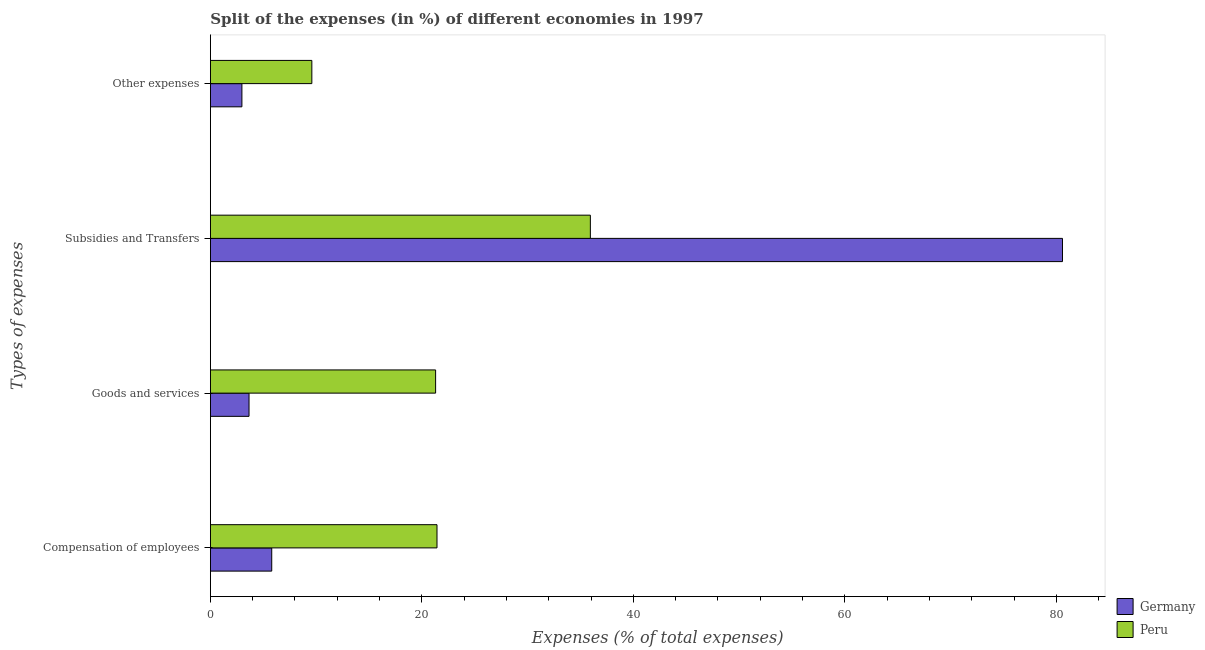Are the number of bars on each tick of the Y-axis equal?
Keep it short and to the point. Yes. How many bars are there on the 4th tick from the bottom?
Your response must be concise. 2. What is the label of the 1st group of bars from the top?
Your answer should be compact. Other expenses. What is the percentage of amount spent on goods and services in Germany?
Offer a terse response. 3.65. Across all countries, what is the maximum percentage of amount spent on subsidies?
Offer a very short reply. 80.58. Across all countries, what is the minimum percentage of amount spent on other expenses?
Keep it short and to the point. 2.98. What is the total percentage of amount spent on other expenses in the graph?
Provide a succinct answer. 12.57. What is the difference between the percentage of amount spent on goods and services in Germany and that in Peru?
Provide a succinct answer. -17.64. What is the difference between the percentage of amount spent on subsidies in Germany and the percentage of amount spent on goods and services in Peru?
Ensure brevity in your answer.  59.28. What is the average percentage of amount spent on subsidies per country?
Offer a terse response. 58.25. What is the difference between the percentage of amount spent on compensation of employees and percentage of amount spent on goods and services in Peru?
Provide a short and direct response. 0.13. What is the ratio of the percentage of amount spent on compensation of employees in Germany to that in Peru?
Your answer should be compact. 0.27. Is the difference between the percentage of amount spent on other expenses in Germany and Peru greater than the difference between the percentage of amount spent on subsidies in Germany and Peru?
Offer a terse response. No. What is the difference between the highest and the second highest percentage of amount spent on subsidies?
Provide a short and direct response. 44.65. What is the difference between the highest and the lowest percentage of amount spent on other expenses?
Make the answer very short. 6.61. In how many countries, is the percentage of amount spent on subsidies greater than the average percentage of amount spent on subsidies taken over all countries?
Offer a very short reply. 1. Is the sum of the percentage of amount spent on subsidies in Germany and Peru greater than the maximum percentage of amount spent on goods and services across all countries?
Offer a terse response. Yes. Is it the case that in every country, the sum of the percentage of amount spent on goods and services and percentage of amount spent on compensation of employees is greater than the sum of percentage of amount spent on subsidies and percentage of amount spent on other expenses?
Provide a succinct answer. No. What does the 1st bar from the top in Compensation of employees represents?
Offer a very short reply. Peru. Is it the case that in every country, the sum of the percentage of amount spent on compensation of employees and percentage of amount spent on goods and services is greater than the percentage of amount spent on subsidies?
Your answer should be compact. No. How many bars are there?
Your response must be concise. 8. What is the difference between two consecutive major ticks on the X-axis?
Your response must be concise. 20. Does the graph contain any zero values?
Make the answer very short. No. Where does the legend appear in the graph?
Keep it short and to the point. Bottom right. How many legend labels are there?
Provide a short and direct response. 2. What is the title of the graph?
Provide a succinct answer. Split of the expenses (in %) of different economies in 1997. Does "Samoa" appear as one of the legend labels in the graph?
Offer a very short reply. No. What is the label or title of the X-axis?
Your response must be concise. Expenses (% of total expenses). What is the label or title of the Y-axis?
Your response must be concise. Types of expenses. What is the Expenses (% of total expenses) in Germany in Compensation of employees?
Provide a short and direct response. 5.8. What is the Expenses (% of total expenses) in Peru in Compensation of employees?
Your response must be concise. 21.43. What is the Expenses (% of total expenses) of Germany in Goods and services?
Provide a succinct answer. 3.65. What is the Expenses (% of total expenses) in Peru in Goods and services?
Make the answer very short. 21.3. What is the Expenses (% of total expenses) of Germany in Subsidies and Transfers?
Your answer should be very brief. 80.58. What is the Expenses (% of total expenses) of Peru in Subsidies and Transfers?
Keep it short and to the point. 35.93. What is the Expenses (% of total expenses) of Germany in Other expenses?
Provide a short and direct response. 2.98. What is the Expenses (% of total expenses) of Peru in Other expenses?
Offer a terse response. 9.59. Across all Types of expenses, what is the maximum Expenses (% of total expenses) of Germany?
Ensure brevity in your answer.  80.58. Across all Types of expenses, what is the maximum Expenses (% of total expenses) in Peru?
Provide a succinct answer. 35.93. Across all Types of expenses, what is the minimum Expenses (% of total expenses) of Germany?
Your answer should be compact. 2.98. Across all Types of expenses, what is the minimum Expenses (% of total expenses) in Peru?
Provide a succinct answer. 9.59. What is the total Expenses (% of total expenses) of Germany in the graph?
Keep it short and to the point. 93.01. What is the total Expenses (% of total expenses) of Peru in the graph?
Provide a succinct answer. 88.25. What is the difference between the Expenses (% of total expenses) of Germany in Compensation of employees and that in Goods and services?
Your answer should be compact. 2.15. What is the difference between the Expenses (% of total expenses) of Peru in Compensation of employees and that in Goods and services?
Keep it short and to the point. 0.13. What is the difference between the Expenses (% of total expenses) of Germany in Compensation of employees and that in Subsidies and Transfers?
Keep it short and to the point. -74.78. What is the difference between the Expenses (% of total expenses) of Peru in Compensation of employees and that in Subsidies and Transfers?
Make the answer very short. -14.5. What is the difference between the Expenses (% of total expenses) in Germany in Compensation of employees and that in Other expenses?
Offer a terse response. 2.82. What is the difference between the Expenses (% of total expenses) of Peru in Compensation of employees and that in Other expenses?
Your answer should be very brief. 11.84. What is the difference between the Expenses (% of total expenses) of Germany in Goods and services and that in Subsidies and Transfers?
Provide a succinct answer. -76.92. What is the difference between the Expenses (% of total expenses) in Peru in Goods and services and that in Subsidies and Transfers?
Give a very brief answer. -14.63. What is the difference between the Expenses (% of total expenses) in Germany in Goods and services and that in Other expenses?
Your answer should be compact. 0.67. What is the difference between the Expenses (% of total expenses) in Peru in Goods and services and that in Other expenses?
Provide a succinct answer. 11.7. What is the difference between the Expenses (% of total expenses) in Germany in Subsidies and Transfers and that in Other expenses?
Give a very brief answer. 77.6. What is the difference between the Expenses (% of total expenses) in Peru in Subsidies and Transfers and that in Other expenses?
Make the answer very short. 26.34. What is the difference between the Expenses (% of total expenses) of Germany in Compensation of employees and the Expenses (% of total expenses) of Peru in Goods and services?
Your response must be concise. -15.5. What is the difference between the Expenses (% of total expenses) in Germany in Compensation of employees and the Expenses (% of total expenses) in Peru in Subsidies and Transfers?
Ensure brevity in your answer.  -30.13. What is the difference between the Expenses (% of total expenses) in Germany in Compensation of employees and the Expenses (% of total expenses) in Peru in Other expenses?
Offer a very short reply. -3.79. What is the difference between the Expenses (% of total expenses) of Germany in Goods and services and the Expenses (% of total expenses) of Peru in Subsidies and Transfers?
Make the answer very short. -32.28. What is the difference between the Expenses (% of total expenses) in Germany in Goods and services and the Expenses (% of total expenses) in Peru in Other expenses?
Ensure brevity in your answer.  -5.94. What is the difference between the Expenses (% of total expenses) in Germany in Subsidies and Transfers and the Expenses (% of total expenses) in Peru in Other expenses?
Give a very brief answer. 70.98. What is the average Expenses (% of total expenses) of Germany per Types of expenses?
Provide a succinct answer. 23.25. What is the average Expenses (% of total expenses) of Peru per Types of expenses?
Keep it short and to the point. 22.06. What is the difference between the Expenses (% of total expenses) of Germany and Expenses (% of total expenses) of Peru in Compensation of employees?
Offer a terse response. -15.63. What is the difference between the Expenses (% of total expenses) of Germany and Expenses (% of total expenses) of Peru in Goods and services?
Your response must be concise. -17.64. What is the difference between the Expenses (% of total expenses) of Germany and Expenses (% of total expenses) of Peru in Subsidies and Transfers?
Your answer should be compact. 44.65. What is the difference between the Expenses (% of total expenses) of Germany and Expenses (% of total expenses) of Peru in Other expenses?
Keep it short and to the point. -6.61. What is the ratio of the Expenses (% of total expenses) of Germany in Compensation of employees to that in Goods and services?
Ensure brevity in your answer.  1.59. What is the ratio of the Expenses (% of total expenses) of Peru in Compensation of employees to that in Goods and services?
Offer a very short reply. 1.01. What is the ratio of the Expenses (% of total expenses) in Germany in Compensation of employees to that in Subsidies and Transfers?
Provide a succinct answer. 0.07. What is the ratio of the Expenses (% of total expenses) of Peru in Compensation of employees to that in Subsidies and Transfers?
Provide a succinct answer. 0.6. What is the ratio of the Expenses (% of total expenses) of Germany in Compensation of employees to that in Other expenses?
Your answer should be compact. 1.95. What is the ratio of the Expenses (% of total expenses) of Peru in Compensation of employees to that in Other expenses?
Your answer should be compact. 2.23. What is the ratio of the Expenses (% of total expenses) in Germany in Goods and services to that in Subsidies and Transfers?
Provide a succinct answer. 0.05. What is the ratio of the Expenses (% of total expenses) of Peru in Goods and services to that in Subsidies and Transfers?
Give a very brief answer. 0.59. What is the ratio of the Expenses (% of total expenses) in Germany in Goods and services to that in Other expenses?
Offer a very short reply. 1.23. What is the ratio of the Expenses (% of total expenses) in Peru in Goods and services to that in Other expenses?
Give a very brief answer. 2.22. What is the ratio of the Expenses (% of total expenses) of Germany in Subsidies and Transfers to that in Other expenses?
Offer a very short reply. 27.03. What is the ratio of the Expenses (% of total expenses) of Peru in Subsidies and Transfers to that in Other expenses?
Make the answer very short. 3.75. What is the difference between the highest and the second highest Expenses (% of total expenses) of Germany?
Your answer should be very brief. 74.78. What is the difference between the highest and the second highest Expenses (% of total expenses) of Peru?
Your answer should be compact. 14.5. What is the difference between the highest and the lowest Expenses (% of total expenses) in Germany?
Your response must be concise. 77.6. What is the difference between the highest and the lowest Expenses (% of total expenses) of Peru?
Your response must be concise. 26.34. 